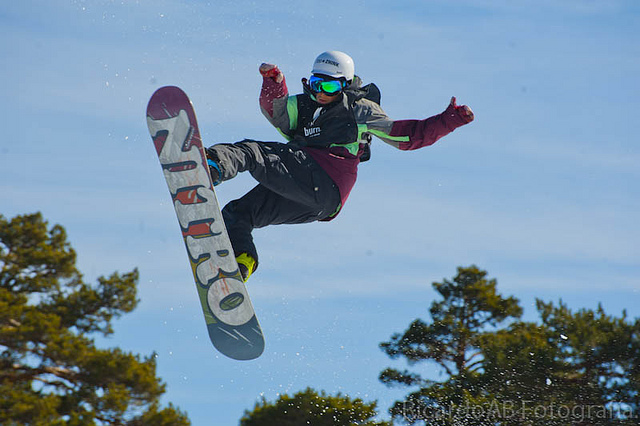Extract all visible text content from this image. FOTOGRAPH NITRO burn 